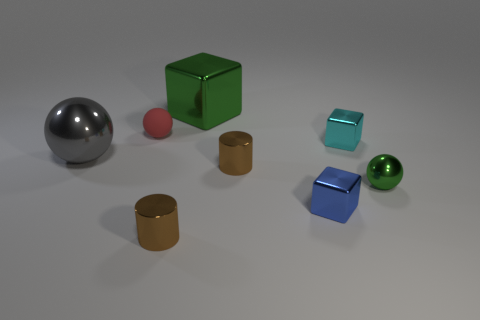Subtract all small balls. How many balls are left? 1 Add 1 matte spheres. How many objects exist? 9 Subtract 1 balls. How many balls are left? 2 Subtract all large gray shiny balls. Subtract all tiny green things. How many objects are left? 6 Add 6 green metal objects. How many green metal objects are left? 8 Add 7 shiny cylinders. How many shiny cylinders exist? 9 Subtract 0 purple balls. How many objects are left? 8 Subtract all balls. How many objects are left? 5 Subtract all red cylinders. Subtract all red spheres. How many cylinders are left? 2 